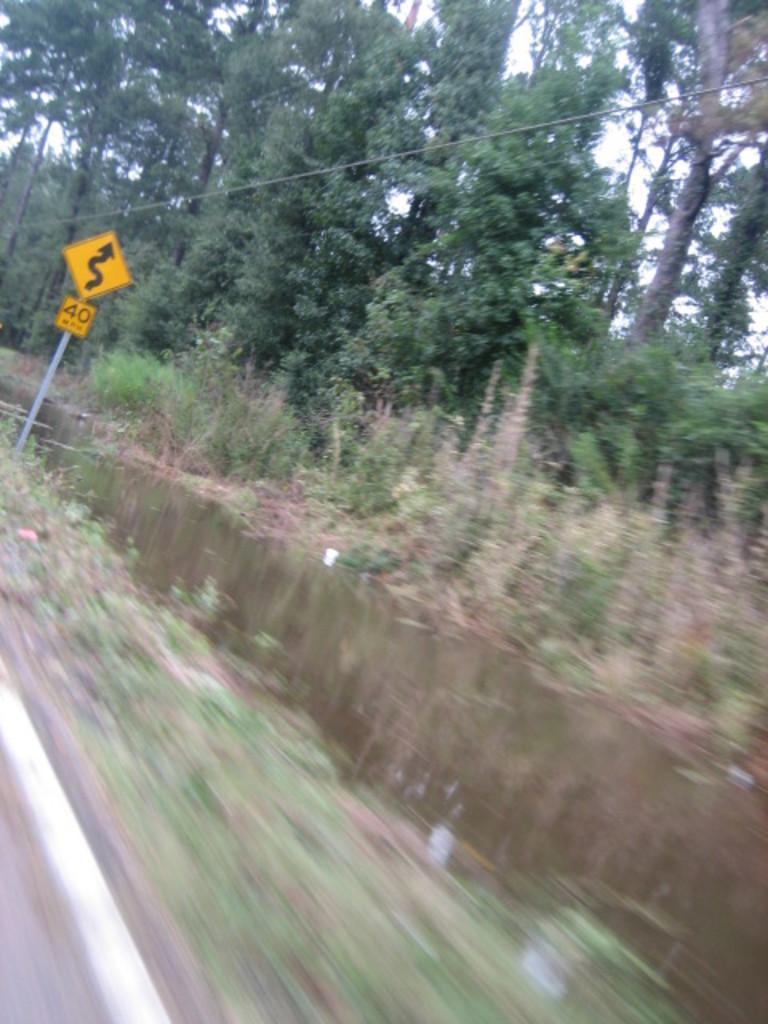Can you describe this image briefly? In this image we can water. On the left side, we can see a signboard with some text. In the background, we can see trees and sky. 